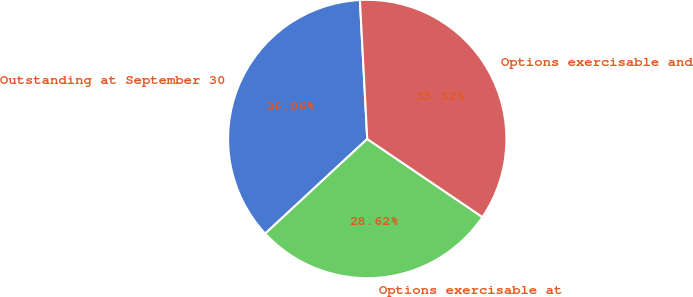<chart> <loc_0><loc_0><loc_500><loc_500><pie_chart><fcel>Outstanding at September 30<fcel>Options exercisable at<fcel>Options exercisable and<nl><fcel>36.06%<fcel>28.62%<fcel>35.32%<nl></chart> 